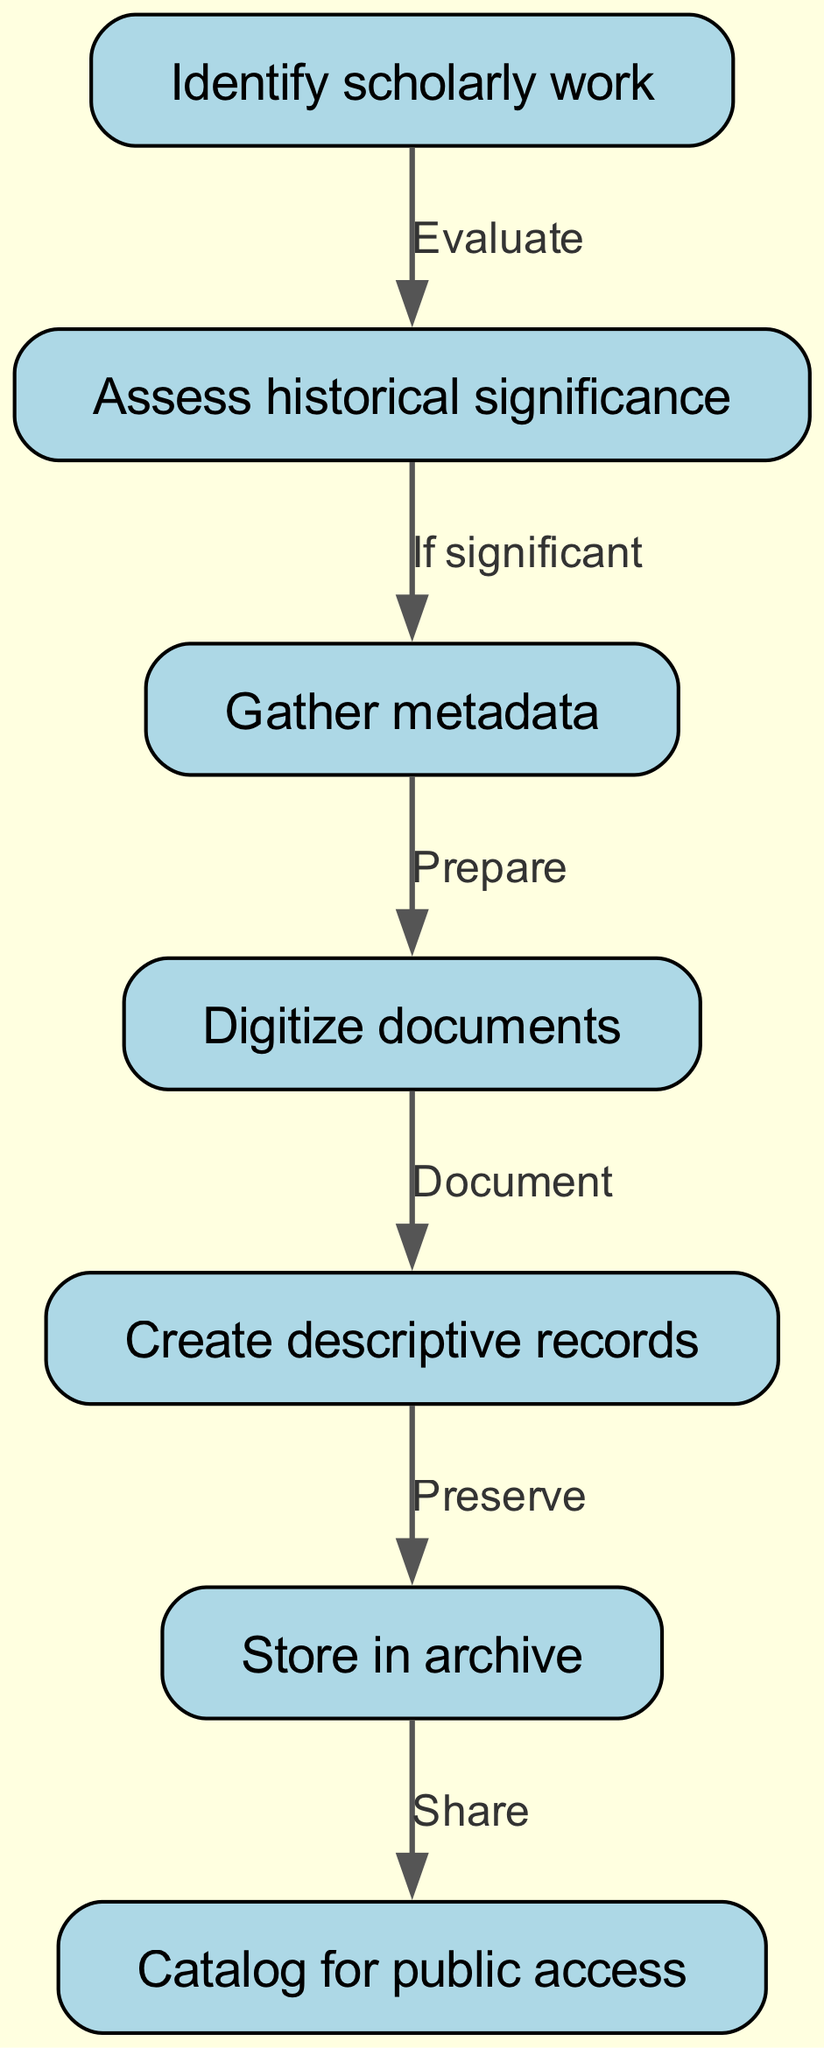What is the first step in the documentation process? The first node in the flowchart shows "Identify scholarly work" as the starting point of the process.
Answer: Identify scholarly work How many total nodes are there in the diagram? By counting the nodes listed in the diagram, we see there are a total of 7 nodes indicating steps in documenting and archiving scholarly works.
Answer: 7 What is the relationship between "Assess historical significance" and "Gather metadata"? According to the diagram, the flow from "Assess historical significance" indicates a conditional path that leads to "Gather metadata" if the work is deemed significant.
Answer: If significant Which step comes directly after "Digitize documents"? From the flowchart, after the step "Digitize documents," the next step is "Create descriptive records," following the order of operations presented.
Answer: Create descriptive records Which node represents the final step in the archiving process? The last node in the flowchart is "Catalog for public access," showing that after storing in the archive, the information is made available to the public.
Answer: Catalog for public access What do you need to do after "Gather metadata"? The diagram indicates that the next step after "Gather metadata" is to "Digitize documents," connecting the collection of metadata with the preparation of documents.
Answer: Digitize documents Which two steps are directly linked to "Store in archive"? The diagram shows that "Store in archive" is the outcome of "Create descriptive records," and the following step is "Catalog for public access," thus linking these three components in the workflow.
Answer: Create descriptive records, Catalog for public access What does "Document" refer to in this context? The term "Document," which comes after "Digitize documents," pertains to creating descriptive records about the scholarly work, ensuring it is well-preserved and described accurately.
Answer: Create descriptive records 